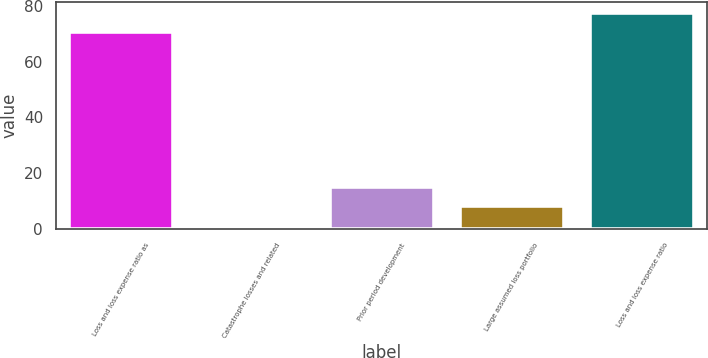Convert chart to OTSL. <chart><loc_0><loc_0><loc_500><loc_500><bar_chart><fcel>Loss and loss expense ratio as<fcel>Catastrophe losses and related<fcel>Prior period development<fcel>Large assumed loss portfolio<fcel>Loss and loss expense ratio<nl><fcel>70.6<fcel>1<fcel>15.1<fcel>8.05<fcel>77.65<nl></chart> 